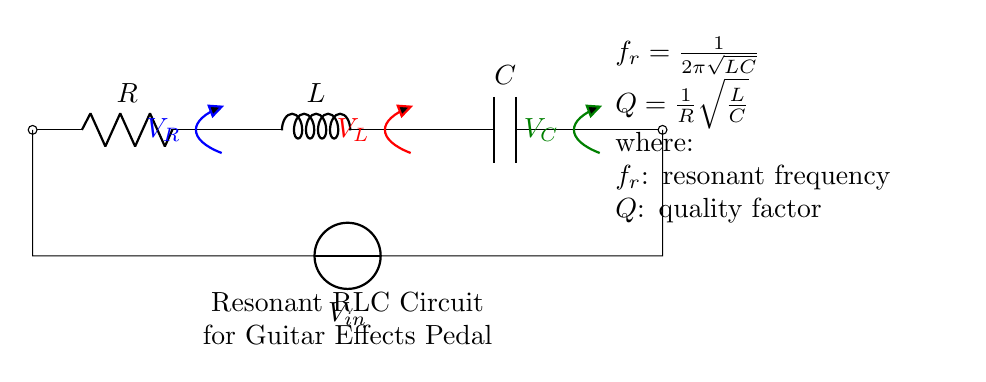What are the components in this circuit? The circuit consists of a resistor, an inductor, and a capacitor, which are typical components used in RLC circuits. These are labeled as R, L, and C in the diagram.
Answer: Resistor, Inductor, Capacitor What does the symbol V represent in this circuit? In the circuit, V represents the input voltage applied across the RLC components, indicating the source of electrical energy driving the circuit.
Answer: Input Voltage What is the formula for resonant frequency shown in the circuit? The resonant frequency formula provided in the circuit is f_r = 1/(2π√(LC)), which indicates how the resonant frequency depends on the values of L and C. It reflects the characteristic frequency at which the circuit can oscillate.
Answer: f_r = 1/(2π√(LC)) What is the significance of the quality factor Q in this circuit? The quality factor Q, calculated as Q = (1/R)√(L/C), indicates the selectivity or sharpness of the resonance of the circuit. A higher Q value signifies a sharper resonance peak, which can affect the tone of a guitar effect pedal by determining how 'ringing' or sustained the sound is.
Answer: Q = (1/R)√(L/C) How does increasing the capacitance affect the resonant frequency? Increasing the capacitance C in the formula f_r = 1/(2π√(LC)) will lead to a decrease in the resonant frequency f_r. This is because capacitance is inversely proportional to resonant frequency; a larger capacitor allows for lower frequencies.
Answer: Decreases resonant frequency What component would you modify to increase the Q factor? To increase the Q factor, you would modify the resistor R. A smaller resistance results in a higher Q factor according to the formula Q = (1/R)√(L/C), indicating that the circuit would have a sharper resonance.
Answer: Resistor What role does the inductor play in this circuit? The inductor L primarily contributes to energy storage in the magnetic field during current oscillation. This energy storage is vital for the resonant behavior of the circuit, allowing it to alternate between storing energy in the magnetic field and releasing it through the capacitor.
Answer: Energy storage 